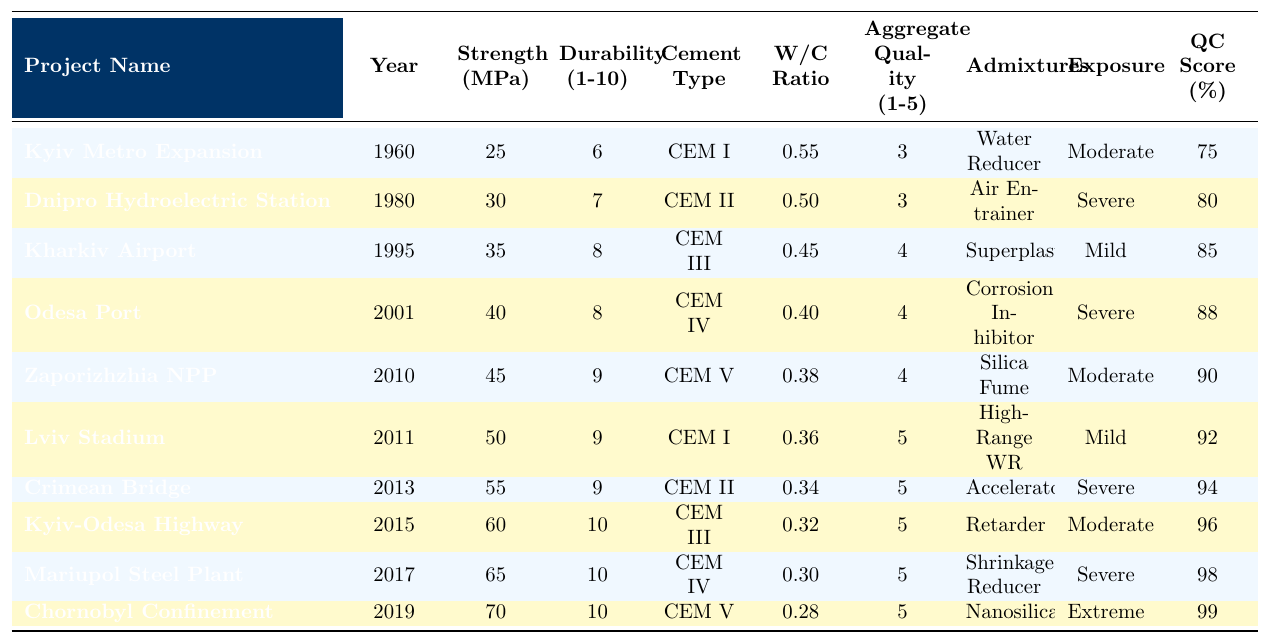What is the highest concrete strength recorded among the projects? The highest value in the "Concrete Strength (MPa)" column is 70, which corresponds to the "Chornobyl New Safe Confinement" project in 2019.
Answer: 70 Which project had the lowest durability rating? The lowest value in the "Durability Rating (1-10)" column is 6, corresponding to the "Kyiv Metro Expansion" project completed in 1960.
Answer: 6 How many projects used CEM II cement? By counting the instances of "CEM II" in the "Cement Type" column, there are 3 projects: "Dnipro Hydroelectric Station Renovation," "Crimean Bridge (pre-2014)," and "Kyiv-Odesa Highway Upgrade."
Answer: 3 What is the average water-cement ratio across all projects? The values in the "Water-Cement Ratio" column are 0.55, 0.50, 0.45, 0.40, 0.38, 0.36, 0.34, 0.32, 0.30, and 0.28. Summing these gives 4.58, and dividing by the number of projects (10) gives an average of 0.458.
Answer: 0.458 Which project had the highest quality control score and what was its score? The highest quality control score in the "Quality Control Score (%)" column is 99, which belongs to the "Chornobyl New Safe Confinement" project completed in 2019.
Answer: 99 Is there any project that has both the highest durability rating and the highest aggregate quality? The "Chornobyl New Safe Confinement" project has a durability rating of 10 and an aggregate quality of 5. Since it fulfills both criteria, the answer is yes.
Answer: Yes Calculate the difference in concrete strength between the oldest and the most recent project. The oldest project, "Kyiv Metro Expansion," has a concrete strength of 25 MPa, while the most recent, "Chornobyl New Safe Confinement," has a strength of 70 MPa. The difference is 70 - 25 = 45.
Answer: 45 What proportion of projects have a durability rating of 10? There are 3 projects ("Kyiv-Odesa Highway Upgrade," "Mariupol Steel Plant Modernization," and "Chornobyl New Safe Confinement") with a durability rating of 10 out of 10 total projects. Proportion = 3/10 = 0.3.
Answer: 0.3 Which type of admixture is used in the "Lviv Stadium Construction" project? The "Lviv Stadium Construction" project used the "High-Range Water Reducer" admixture, as per the corresponding entry in the "Admixtures Used" column.
Answer: High-Range Water Reducer What is the relationship between the year completed and the concrete strength among the projects? Reviewing the "Year Completed" and "Concrete Strength (MPa)" columns shows that concrete strength generally increases over time, with older projects showing lower strengths and newer projects, like "Chornobyl New Safe Confinement," exhibiting the highest.
Answer: Increases over time 